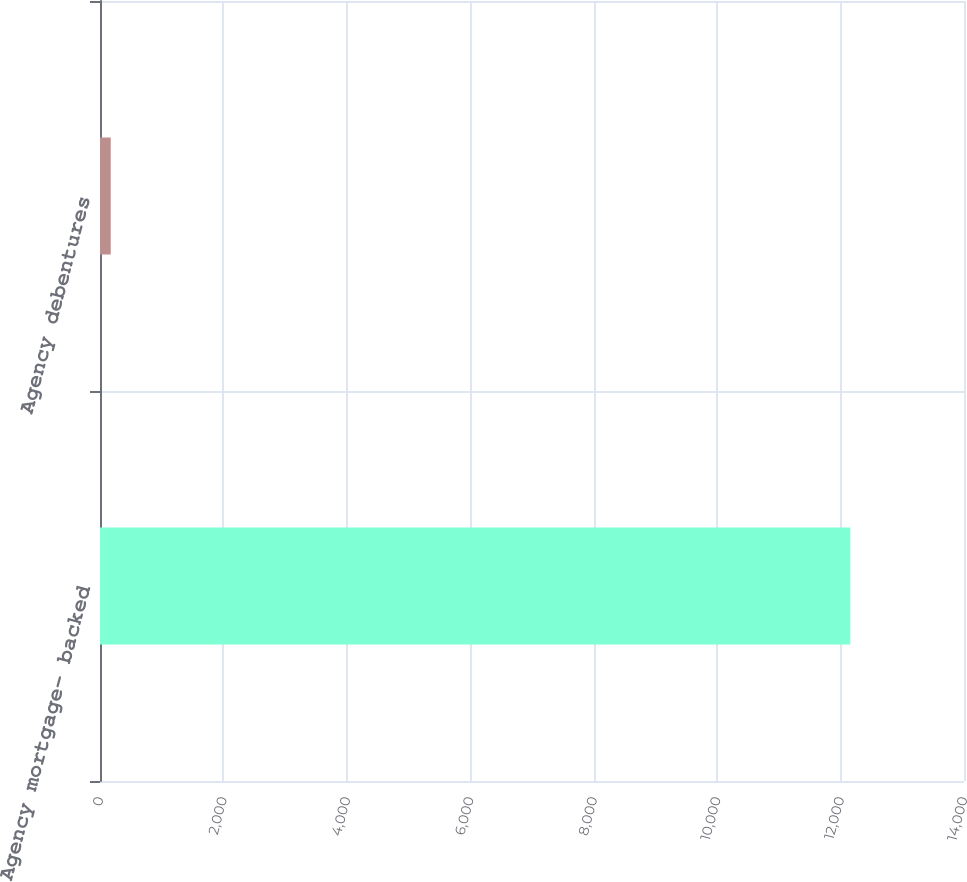Convert chart to OTSL. <chart><loc_0><loc_0><loc_500><loc_500><bar_chart><fcel>Agency mortgage- backed<fcel>Agency debentures<nl><fcel>12157<fcel>174<nl></chart> 